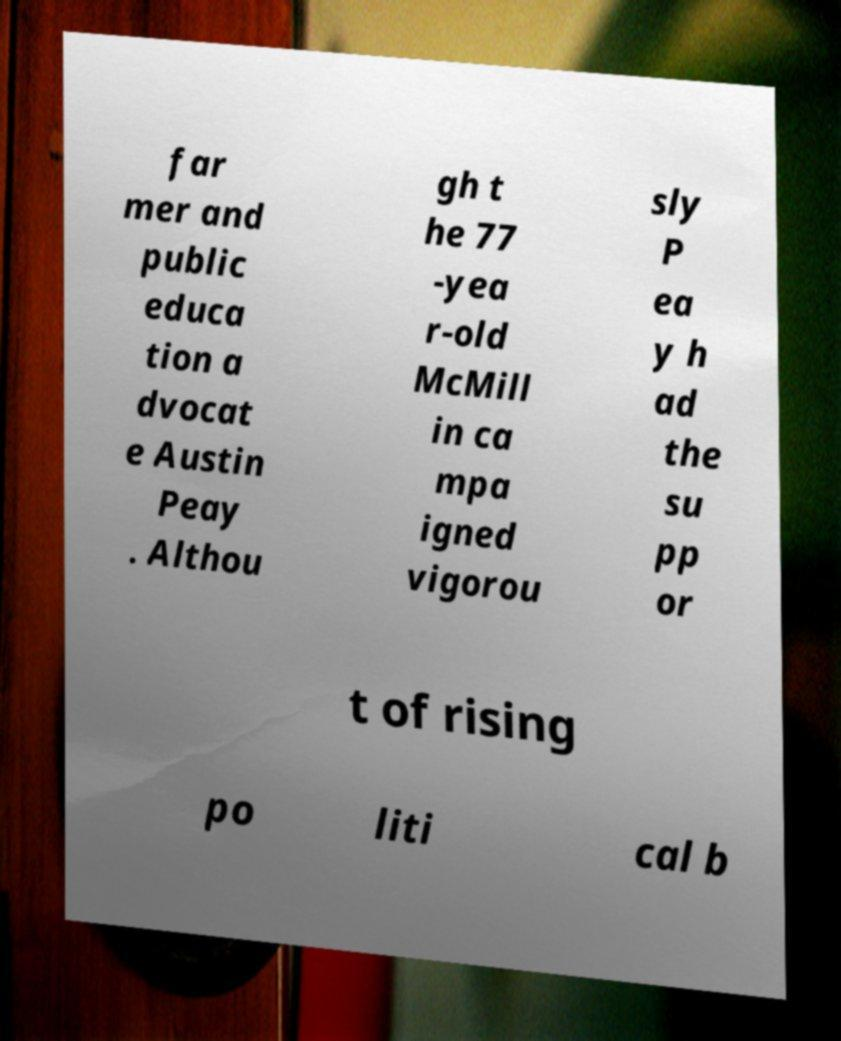Please read and relay the text visible in this image. What does it say? far mer and public educa tion a dvocat e Austin Peay . Althou gh t he 77 -yea r-old McMill in ca mpa igned vigorou sly P ea y h ad the su pp or t of rising po liti cal b 